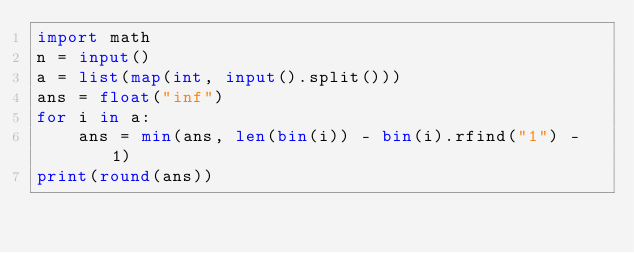Convert code to text. <code><loc_0><loc_0><loc_500><loc_500><_Python_>import math
n = input()
a = list(map(int, input().split()))
ans = float("inf")
for i in a:
    ans = min(ans, len(bin(i)) - bin(i).rfind("1") - 1)
print(round(ans))</code> 